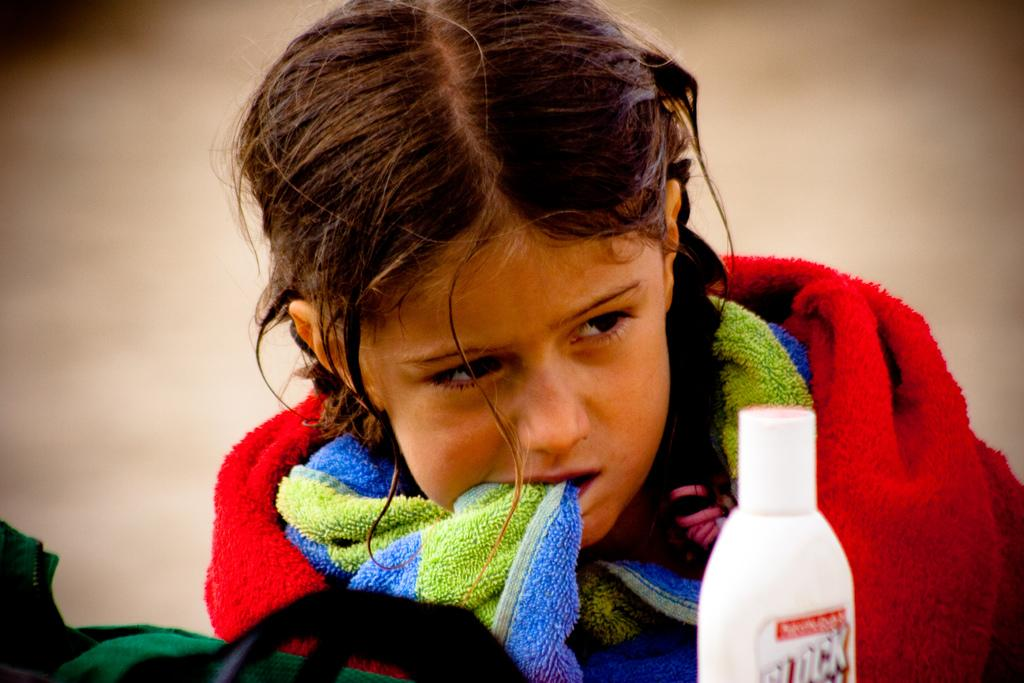Who is the main subject in the image? There is a small girl in the image. What is the girl doing in the image? The girl is covering a towel. Can you describe the towel in the image? The towel has red, blue, and green colors. What object is in front of the girl? There is a white bottle in front of the girl. What type of street can be seen in the image? There is no street visible in the image. Is the girl driving a vehicle in the image? There is no vehicle or driving activity depicted in the image. 